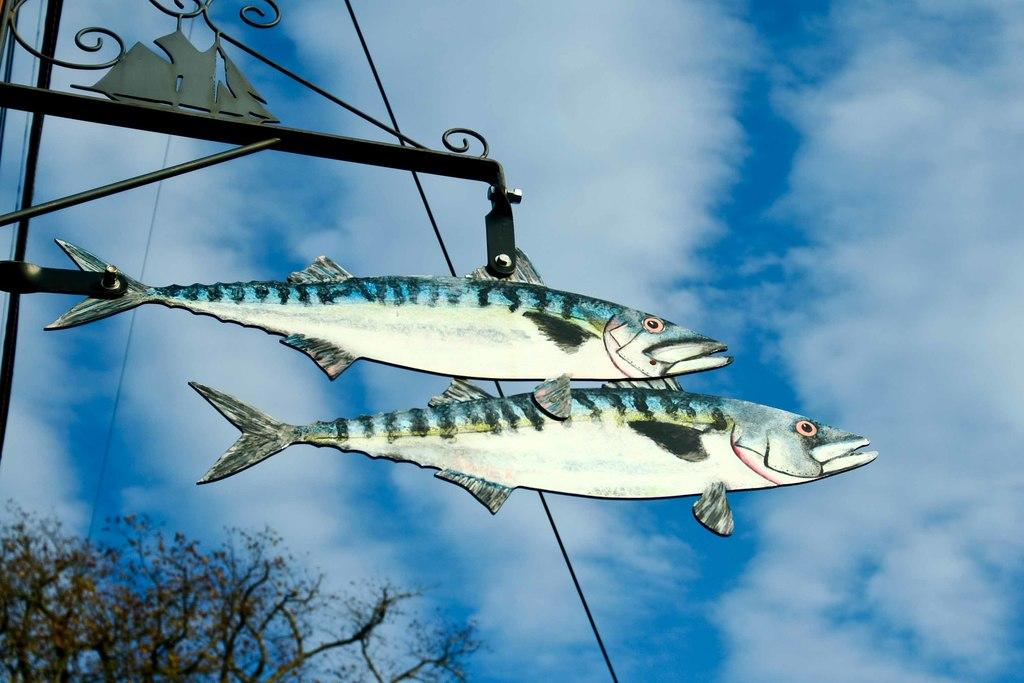What objects are attached to the pole in the image? There are two fish boards attached to a pole in the image. What can be seen in the background of the image? There are trees and the sky visible in the background of the image. What is the color of the trees in the image? The trees are green in the image. What is the color of the sky in the image? The sky is blue and white in color in the image. Where is the stove located in the image? There is no stove present in the image. What type of drug can be seen in the image? There is no drug present in the image. 